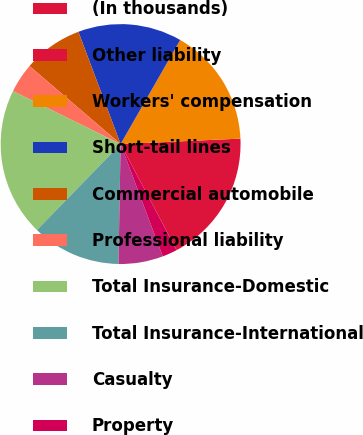Convert chart to OTSL. <chart><loc_0><loc_0><loc_500><loc_500><pie_chart><fcel>(In thousands)<fcel>Other liability<fcel>Workers' compensation<fcel>Short-tail lines<fcel>Commercial automobile<fcel>Professional liability<fcel>Total Insurance-Domestic<fcel>Total Insurance-International<fcel>Casualty<fcel>Property<nl><fcel>0.01%<fcel>17.99%<fcel>16.0%<fcel>14.0%<fcel>8.0%<fcel>4.0%<fcel>19.99%<fcel>12.0%<fcel>6.0%<fcel>2.01%<nl></chart> 